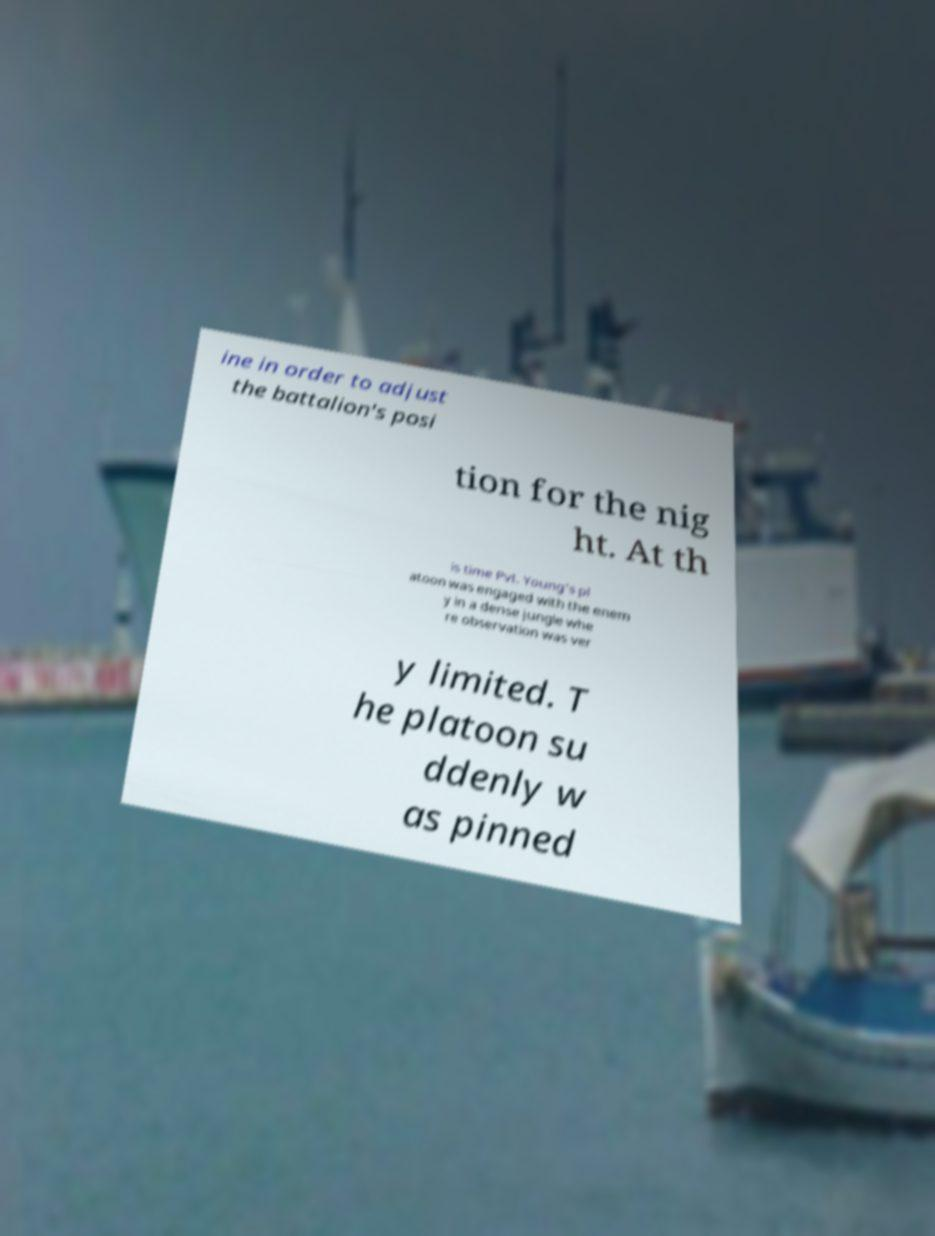Could you extract and type out the text from this image? ine in order to adjust the battalion's posi tion for the nig ht. At th is time Pvt. Young's pl atoon was engaged with the enem y in a dense jungle whe re observation was ver y limited. T he platoon su ddenly w as pinned 